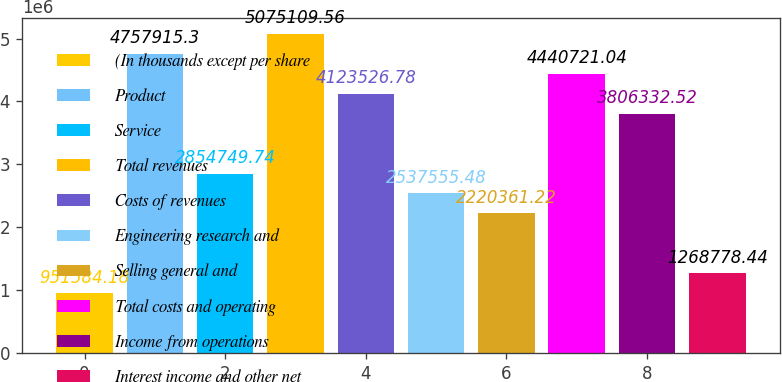Convert chart. <chart><loc_0><loc_0><loc_500><loc_500><bar_chart><fcel>(In thousands except per share<fcel>Product<fcel>Service<fcel>Total revenues<fcel>Costs of revenues<fcel>Engineering research and<fcel>Selling general and<fcel>Total costs and operating<fcel>Income from operations<fcel>Interest income and other net<nl><fcel>951584<fcel>4.75792e+06<fcel>2.85475e+06<fcel>5.07511e+06<fcel>4.12353e+06<fcel>2.53756e+06<fcel>2.22036e+06<fcel>4.44072e+06<fcel>3.80633e+06<fcel>1.26878e+06<nl></chart> 